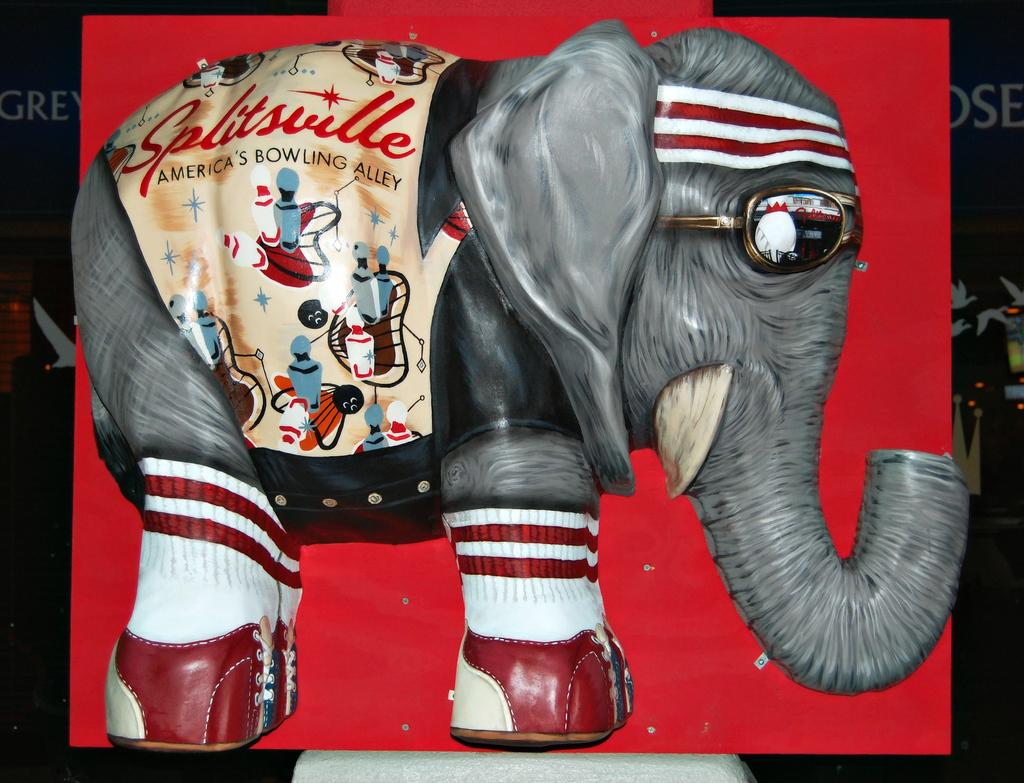What is the main object in the image? There is a board in the image. What is depicted on the board? The board contains a depiction of an elephant. How many sheep can be seen grazing near the brick wall in the image? There are no sheep or brick walls present in the image; it only contains a board with an elephant depicted on it. 